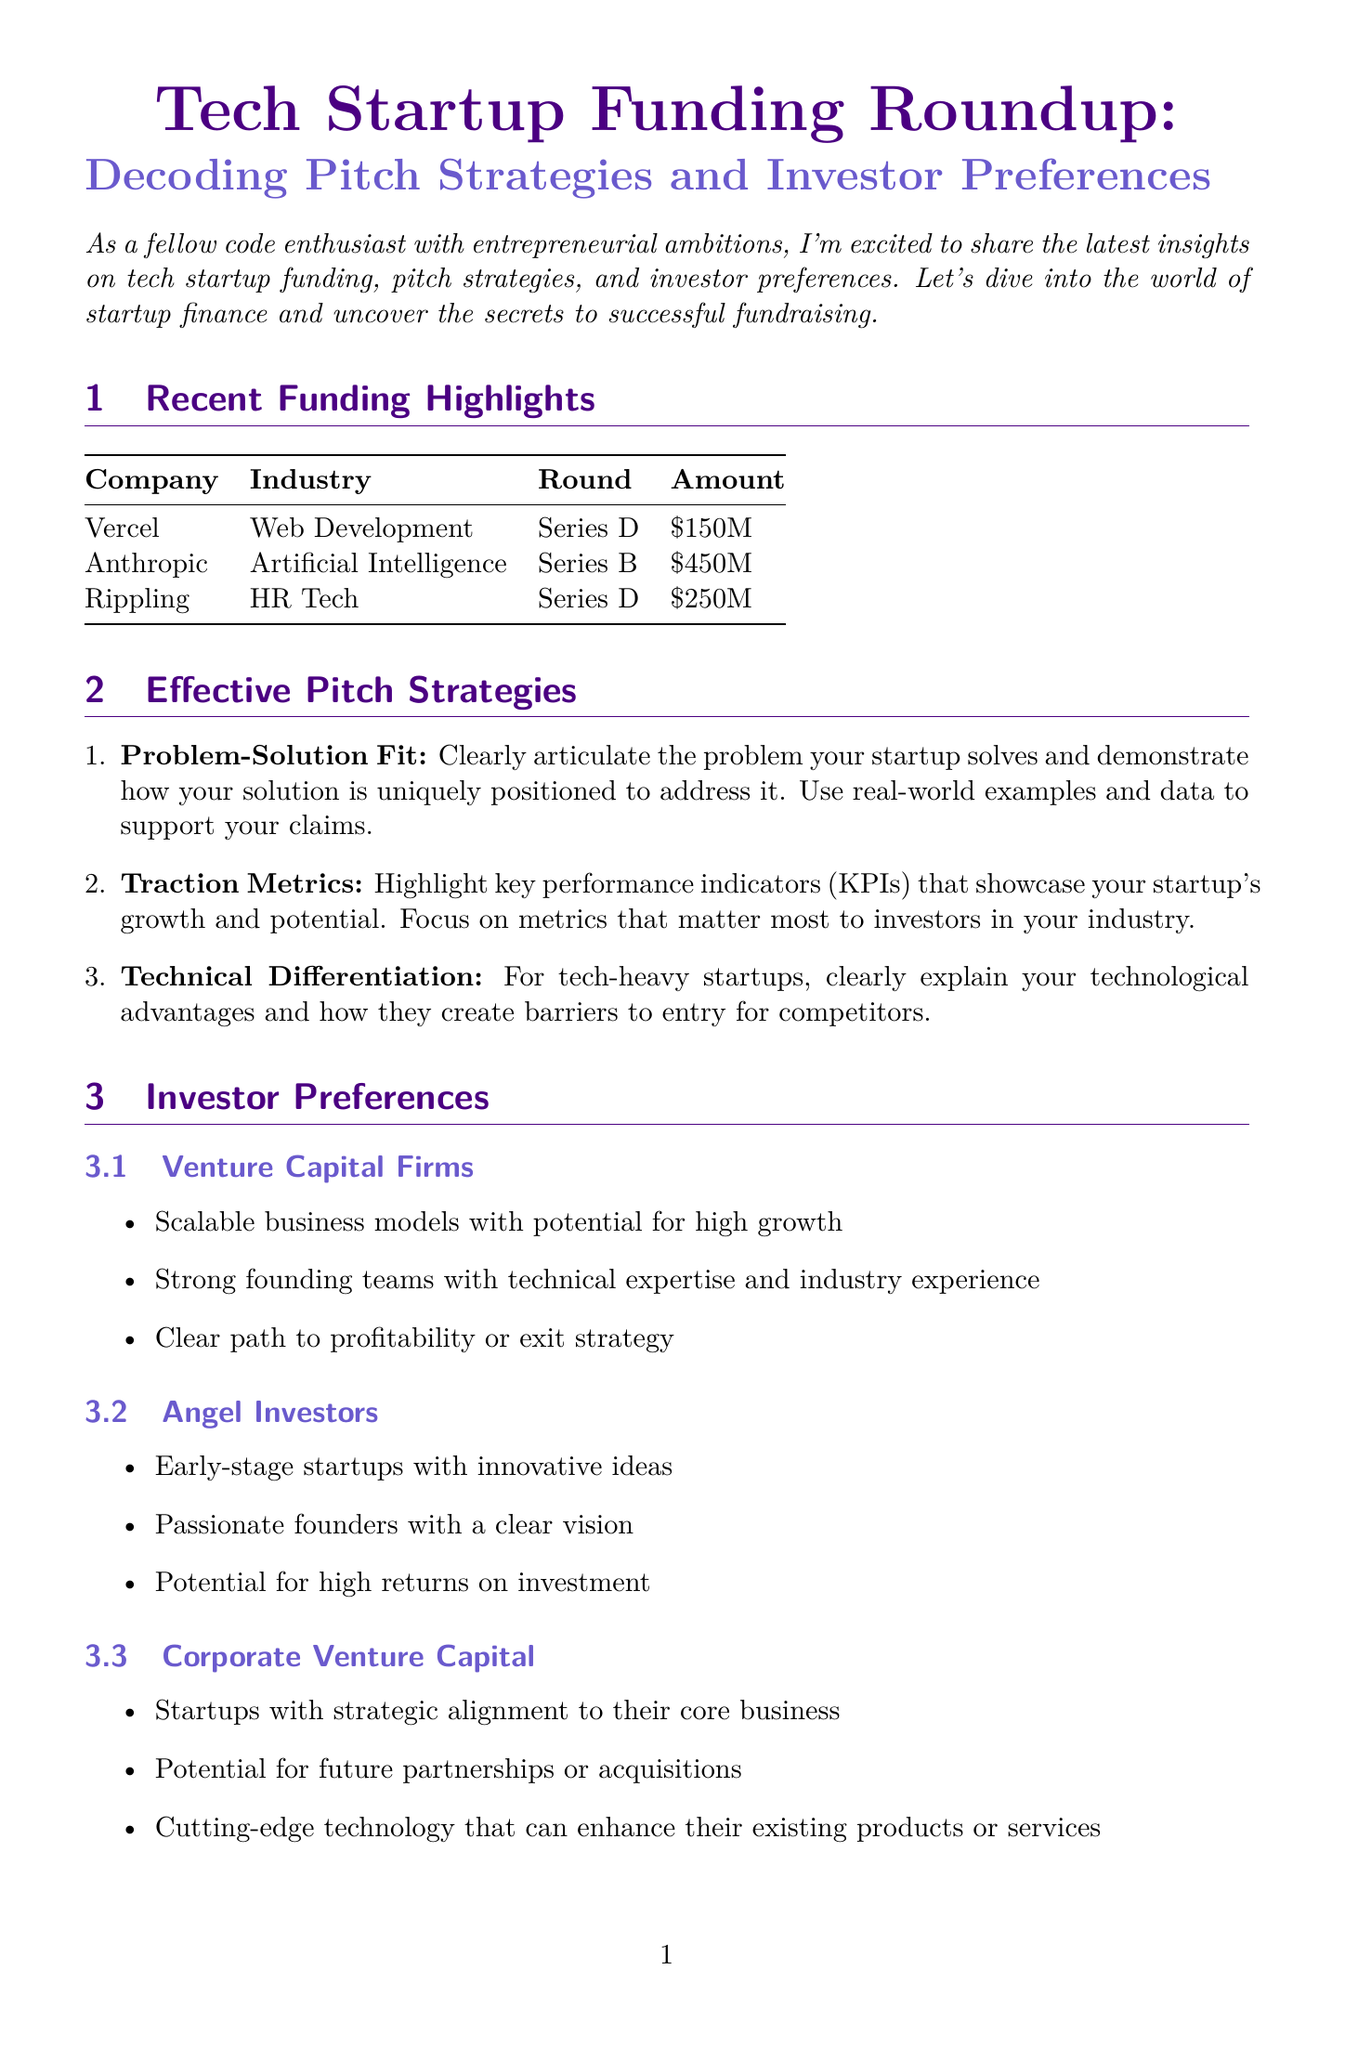What is the title of the newsletter? The title of the newsletter is presented prominently at the beginning of the document.
Answer: Tech Startup Funding Roundup: Decoding Pitch Strategies and Investor Preferences How much did Vercel raise in their funding round? The amount raised by Vercel is listed in the funding highlights section.
Answer: $150 million Which investor led the Series B funding for Anthropic? The lead investor for Anthropic's Series B is mentioned in the funding details.
Answer: Dustin Moskovitz What strategy emphasizes showcasing key performance indicators? The strategies section describes different approaches taken by startups and one focuses on metrics.
Answer: Traction Metrics What is a common preference of Corporate Venture Capital investors? Preferences of different investor types are specified in the preferences section.
Answer: Startups with strategic alignment to their core business Which technology should be used to develop a clean pitch deck? The coding tips section provides recommendations for pitch preparation.
Answer: React or Vue.js What is one example of a firm that prefers scalable business models? Under investor preferences, example firms are listed for each type which includes one for this preference.
Answer: Sequoia Capital What is the funding round for Rippling? The specific funding round for Rippling is indicated in the funding section and is essential information.
Answer: Series D 